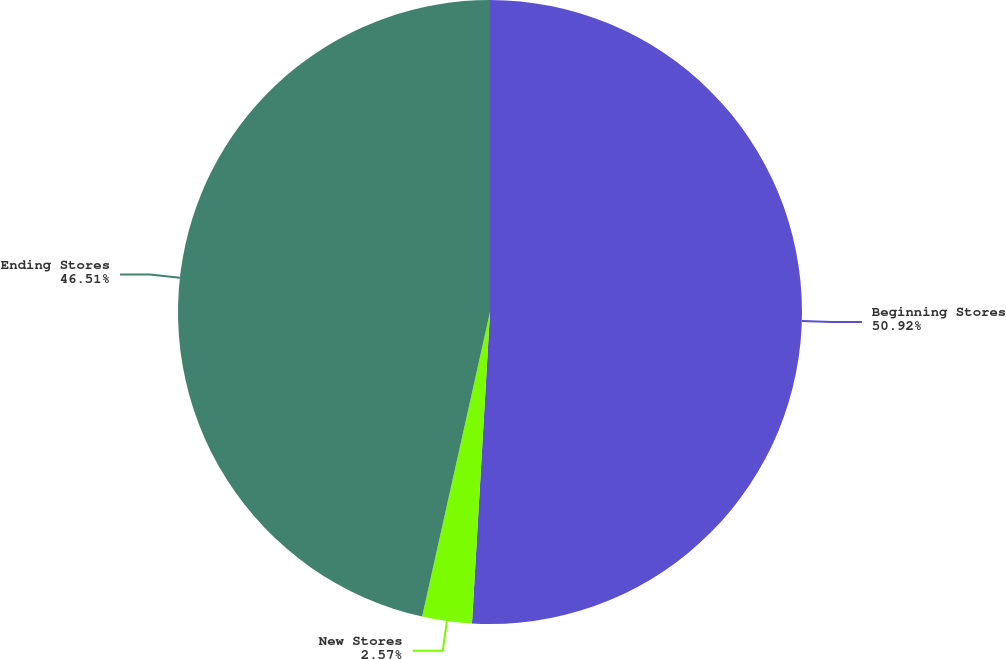Convert chart to OTSL. <chart><loc_0><loc_0><loc_500><loc_500><pie_chart><fcel>Beginning Stores<fcel>New Stores<fcel>Ending Stores<nl><fcel>50.92%<fcel>2.57%<fcel>46.51%<nl></chart> 